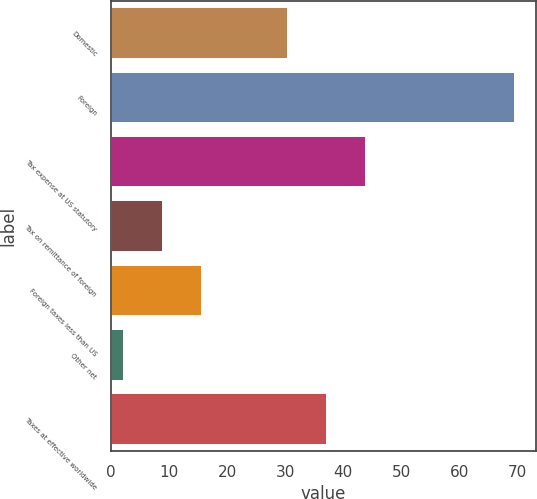Convert chart to OTSL. <chart><loc_0><loc_0><loc_500><loc_500><bar_chart><fcel>Domestic<fcel>Foreign<fcel>Tax expense at US statutory<fcel>Tax on remittance of foreign<fcel>Foreign taxes less than US<fcel>Other net<fcel>Taxes at effective worldwide<nl><fcel>30.4<fcel>69.6<fcel>43.86<fcel>9.03<fcel>15.76<fcel>2.3<fcel>37.13<nl></chart> 